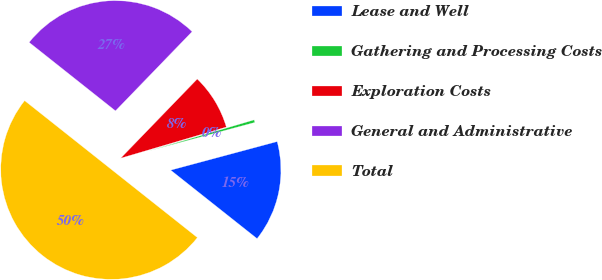Convert chart. <chart><loc_0><loc_0><loc_500><loc_500><pie_chart><fcel>Lease and Well<fcel>Gathering and Processing Costs<fcel>Exploration Costs<fcel>General and Administrative<fcel>Total<nl><fcel>14.84%<fcel>0.39%<fcel>8.2%<fcel>26.56%<fcel>50.0%<nl></chart> 